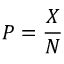Convert formula to latex. <formula><loc_0><loc_0><loc_500><loc_500>P = { \frac { X } { N } }</formula> 